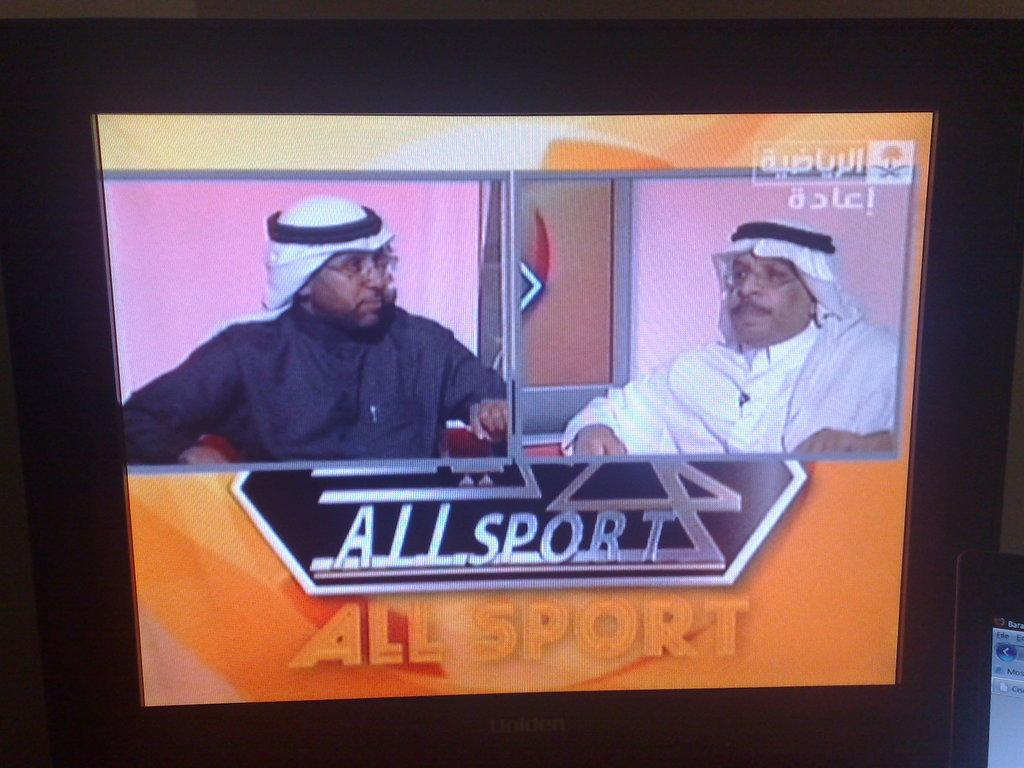<image>
Present a compact description of the photo's key features. The television show All Sport features two men on a split screen. 